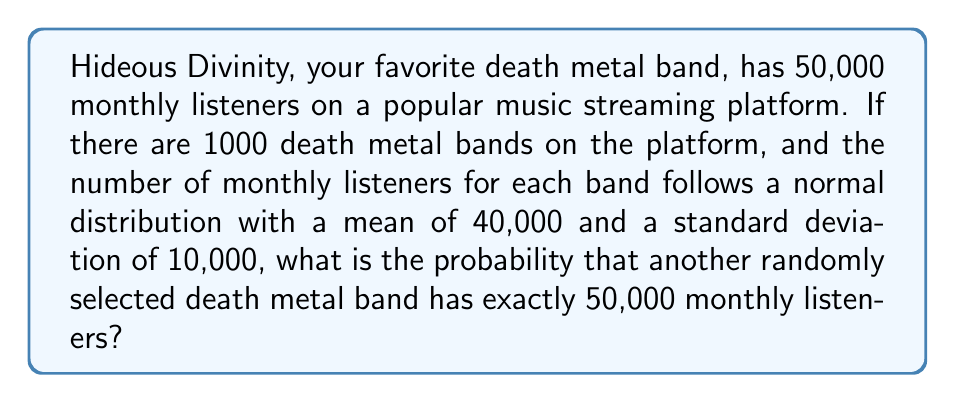Give your solution to this math problem. To solve this problem, we need to follow these steps:

1. Identify the distribution: The number of monthly listeners follows a normal distribution.

2. Determine the parameters:
   Mean (μ) = 40,000
   Standard deviation (σ) = 10,000

3. Calculate the z-score for 50,000 monthly listeners:
   $$z = \frac{x - μ}{σ} = \frac{50,000 - 40,000}{10,000} = 1$$

4. Since we're looking for the probability of exactly 50,000 listeners, we need to use the probability density function (PDF) of the normal distribution:

   $$f(x) = \frac{1}{σ\sqrt{2π}} e^{-\frac{1}{2}(\frac{x-μ}{σ})^2}$$

5. Substitute the values:
   $$f(50,000) = \frac{1}{10,000\sqrt{2π}} e^{-\frac{1}{2}(1)^2}$$

6. Calculate the result:
   $$f(50,000) = \frac{1}{10,000\sqrt{2π}} e^{-0.5} ≈ 0.00002419$$

This value represents the probability density at exactly 50,000 listeners. However, since we're dealing with a continuous distribution, the probability of getting exactly 50,000 listeners is infinitesimally small.

In practice, we often consider a small range around the exact value. For example, we could calculate the probability of having between 49,999.5 and 50,000.5 listeners, which would give us:

$$P(49999.5 < X < 50000.5) = \int_{49999.5}^{50000.5} f(x) dx ≈ 0.00002419$$

This is approximately equal to the value we calculated using the PDF at exactly 50,000.
Answer: $0.00002419$ or $2.419 \times 10^{-5}$ 